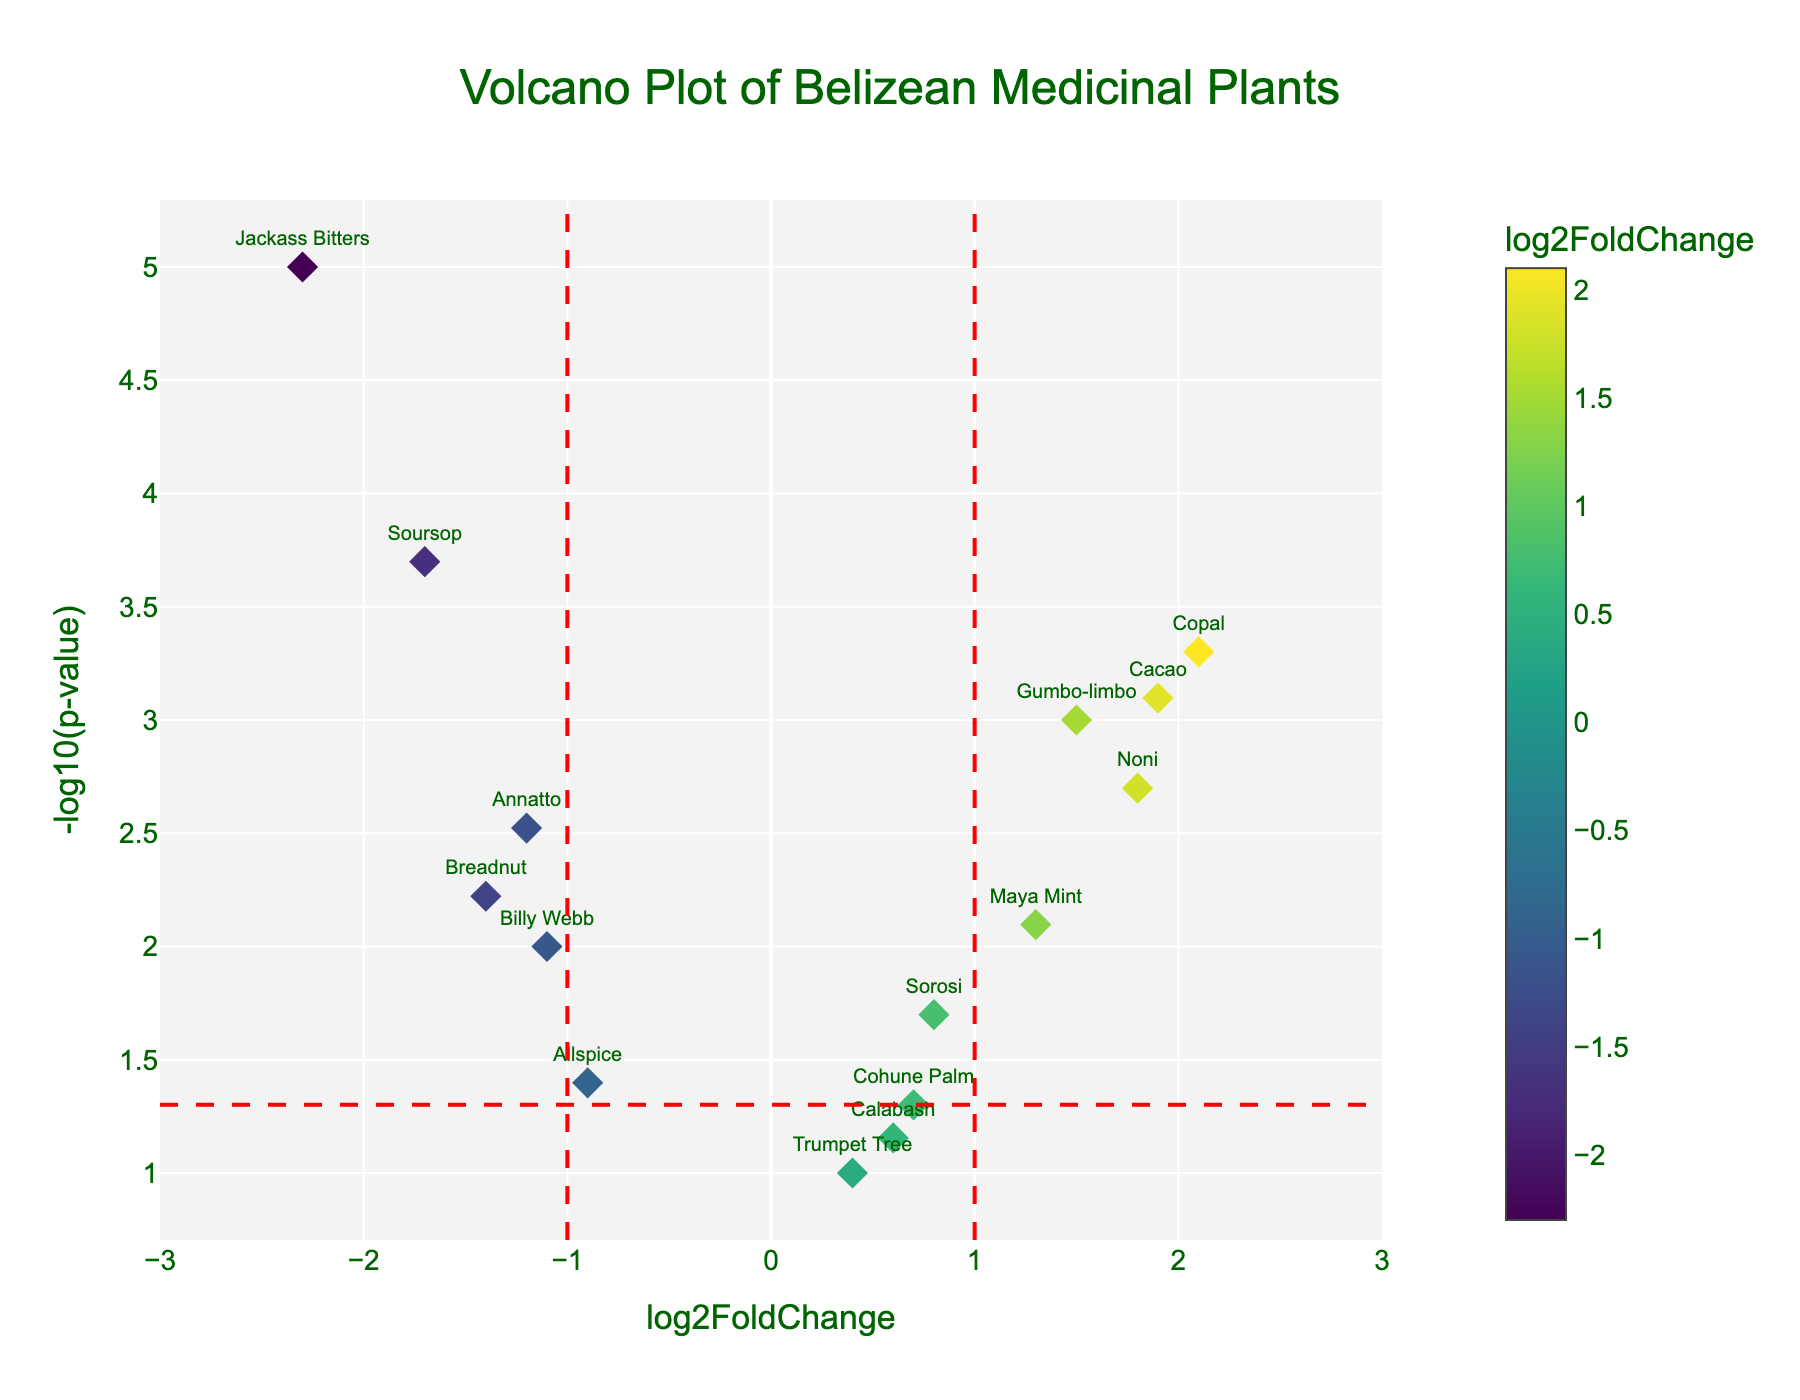What is the title of the plot? The title of the plot is prominently displayed at the top of the figure in a large, dark green font. It reads "Volcano Plot of Belizean Medicinal Plants."
Answer: Volcano Plot of Belizean Medicinal Plants How many compounds are labeled on the plot? Each diamond marker on the plot represents one of the compounds. By counting the labels, we can see that there are 15 different compounds represented on the plot.
Answer: 15 Which compound has the highest log2FoldChange? To find the compound with the highest log2FoldChange, look for the marker farthest to the right on the x-axis. The compound "Copal" has the highest log2FoldChange value of 2.1.
Answer: Copal Which compound has the lowest p-value? The p-value is represented on the y-axis as -log10(p-value). The higher the point on the y-axis, the lower the p-value. "Jackass Bitters" is the highest on the y-axis, indicating it has the lowest p-value.
Answer: Jackass Bitters What does the color represent in the plot? The color of the markers is associated with the log2FoldChange value. This is indicated by the color scale on the right side of the plot, which shows a gradient of colors representing different log2FoldChange values.
Answer: log2FoldChange Are there any compounds with a log2FoldChange lower than -1 and a significant p-value (p < 0.05)? To determine this, find markers to the left of the vertical line at x = -1 and above the horizontal line indicating -log10(0.05). "Annatto," "Jackass Bitters," "Billy Webb," "Breadnut," "Soursop," and "Allspice" meet these criteria.
Answer: Annatto, Jackass Bitters, Billy Webb, Breadnut, Soursop, Allspice Which compounds have a p-value above 0.05? Compounds with a p-value above 0.05 will be below the horizontal red line (-log10(0.05)) on the plot. "Calabash," "Cohune Palm," and "Trumpet Tree" are below this line.
Answer: Calabash, Cohune Palm, Trumpet Tree Between "Noni" and "Maya Mint," which compound has a higher -log10(p-value)? Compare their respective heights on the y-axis. "Noni" is higher than "Maya Mint," indicating that "Noni" has a higher -log10(p-value), and thus a lower p-value.
Answer: Noni What is the log2FoldChange value of "Soursop"? Look for the label "Soursop" on the plot and read the corresponding x-axis value. "Soursop" is positioned at a log2FoldChange value of -1.7.
Answer: -1.7 Which compound has almost the same log2FoldChange as "Sorosi" but is slightly more significant? Compare nearby markers to "Sorosi" (log2FoldChange of 0.8) and check for higher positions on the y-axis (lower p-value). "Noni" (log2FoldChange of 1.8) is more significant and close in log2FoldChange.
Answer: Noni 